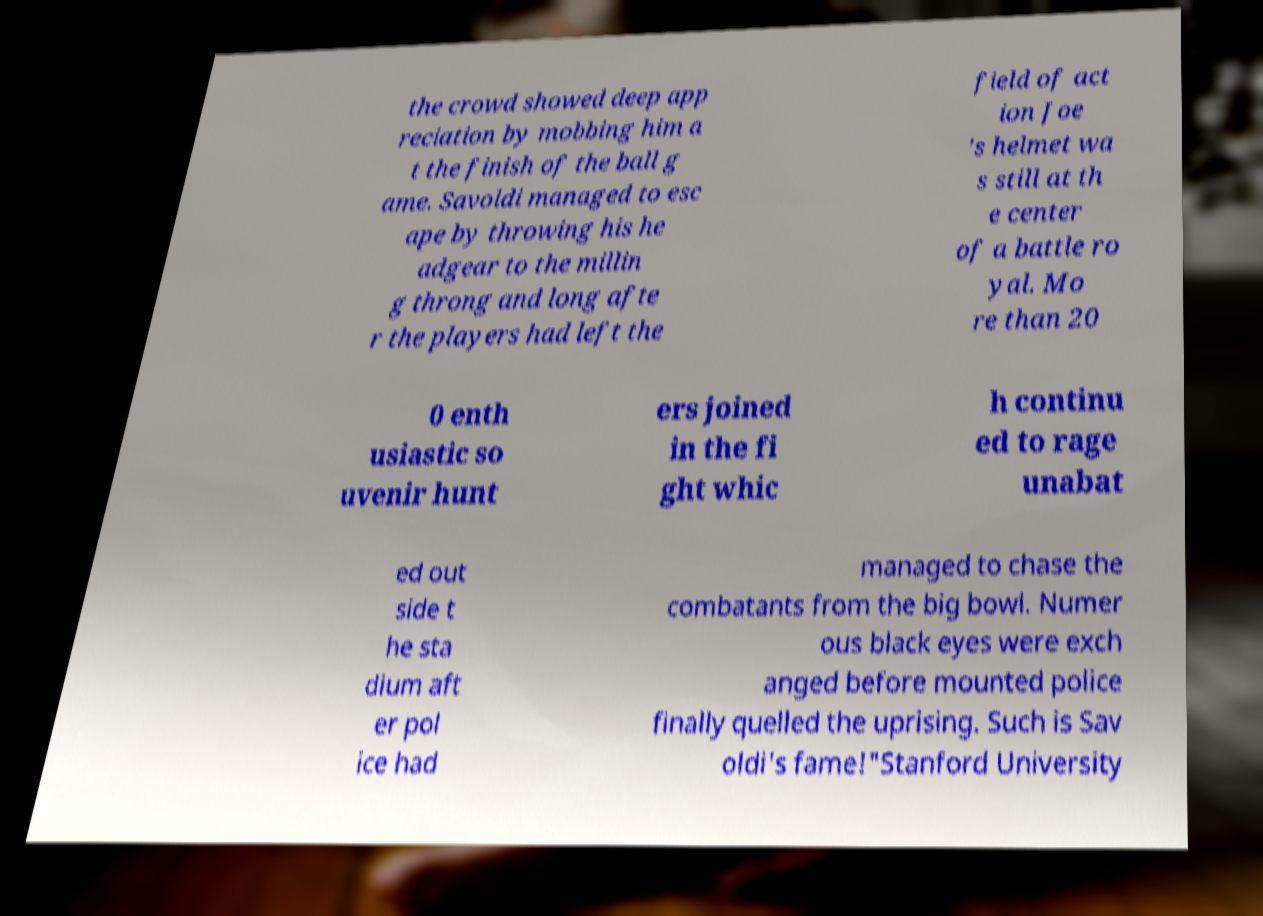I need the written content from this picture converted into text. Can you do that? the crowd showed deep app reciation by mobbing him a t the finish of the ball g ame. Savoldi managed to esc ape by throwing his he adgear to the millin g throng and long afte r the players had left the field of act ion Joe 's helmet wa s still at th e center of a battle ro yal. Mo re than 20 0 enth usiastic so uvenir hunt ers joined in the fi ght whic h continu ed to rage unabat ed out side t he sta dium aft er pol ice had managed to chase the combatants from the big bowl. Numer ous black eyes were exch anged before mounted police finally quelled the uprising. Such is Sav oldi's fame!"Stanford University 